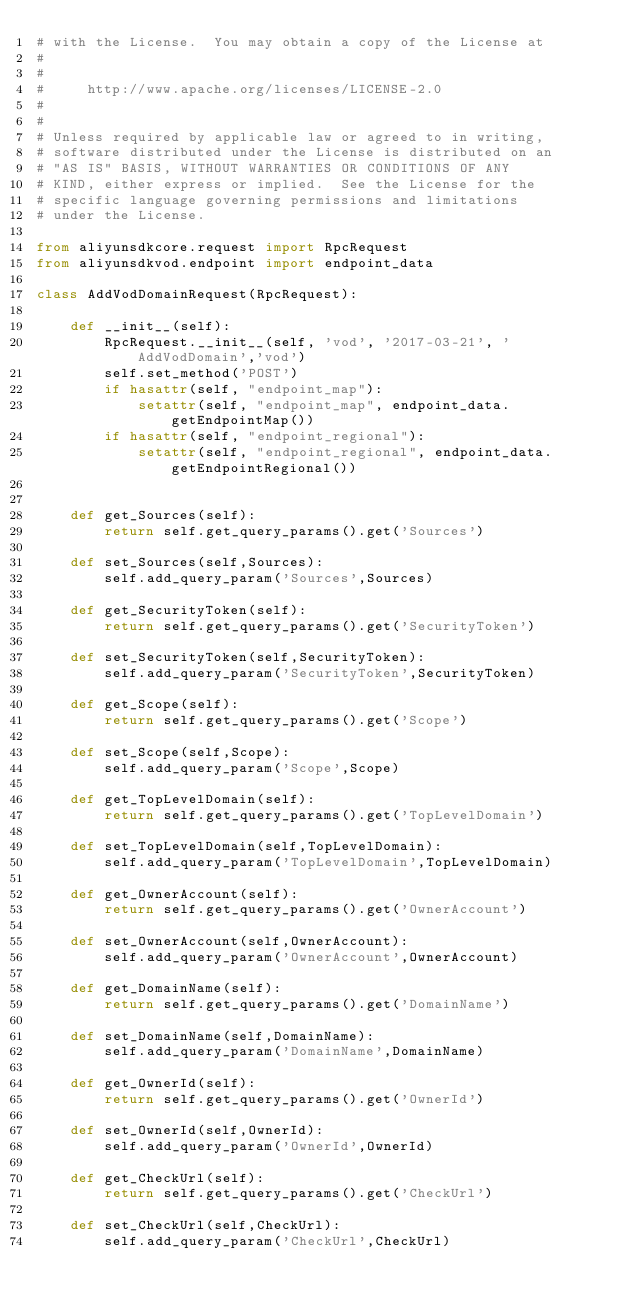Convert code to text. <code><loc_0><loc_0><loc_500><loc_500><_Python_># with the License.  You may obtain a copy of the License at
#
#
#     http://www.apache.org/licenses/LICENSE-2.0
#
#
# Unless required by applicable law or agreed to in writing,
# software distributed under the License is distributed on an
# "AS IS" BASIS, WITHOUT WARRANTIES OR CONDITIONS OF ANY
# KIND, either express or implied.  See the License for the
# specific language governing permissions and limitations
# under the License.

from aliyunsdkcore.request import RpcRequest
from aliyunsdkvod.endpoint import endpoint_data

class AddVodDomainRequest(RpcRequest):

	def __init__(self):
		RpcRequest.__init__(self, 'vod', '2017-03-21', 'AddVodDomain','vod')
		self.set_method('POST')
		if hasattr(self, "endpoint_map"):
			setattr(self, "endpoint_map", endpoint_data.getEndpointMap())
		if hasattr(self, "endpoint_regional"):
			setattr(self, "endpoint_regional", endpoint_data.getEndpointRegional())


	def get_Sources(self):
		return self.get_query_params().get('Sources')

	def set_Sources(self,Sources):
		self.add_query_param('Sources',Sources)

	def get_SecurityToken(self):
		return self.get_query_params().get('SecurityToken')

	def set_SecurityToken(self,SecurityToken):
		self.add_query_param('SecurityToken',SecurityToken)

	def get_Scope(self):
		return self.get_query_params().get('Scope')

	def set_Scope(self,Scope):
		self.add_query_param('Scope',Scope)

	def get_TopLevelDomain(self):
		return self.get_query_params().get('TopLevelDomain')

	def set_TopLevelDomain(self,TopLevelDomain):
		self.add_query_param('TopLevelDomain',TopLevelDomain)

	def get_OwnerAccount(self):
		return self.get_query_params().get('OwnerAccount')

	def set_OwnerAccount(self,OwnerAccount):
		self.add_query_param('OwnerAccount',OwnerAccount)

	def get_DomainName(self):
		return self.get_query_params().get('DomainName')

	def set_DomainName(self,DomainName):
		self.add_query_param('DomainName',DomainName)

	def get_OwnerId(self):
		return self.get_query_params().get('OwnerId')

	def set_OwnerId(self,OwnerId):
		self.add_query_param('OwnerId',OwnerId)

	def get_CheckUrl(self):
		return self.get_query_params().get('CheckUrl')

	def set_CheckUrl(self,CheckUrl):
		self.add_query_param('CheckUrl',CheckUrl)</code> 